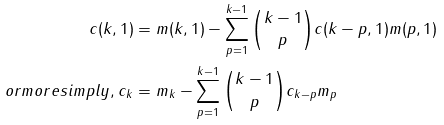Convert formula to latex. <formula><loc_0><loc_0><loc_500><loc_500>c ( k , 1 ) & = m ( k , 1 ) - \sum _ { p = 1 } ^ { k - 1 } \binom { k - 1 } { p } c ( k - p , 1 ) m ( p , 1 ) \\ o r m o r e s i m p l y , c _ { k } & = m _ { k } - \sum _ { p = 1 } ^ { k - 1 } \binom { k - 1 } { p } c _ { k - p } m _ { p }</formula> 